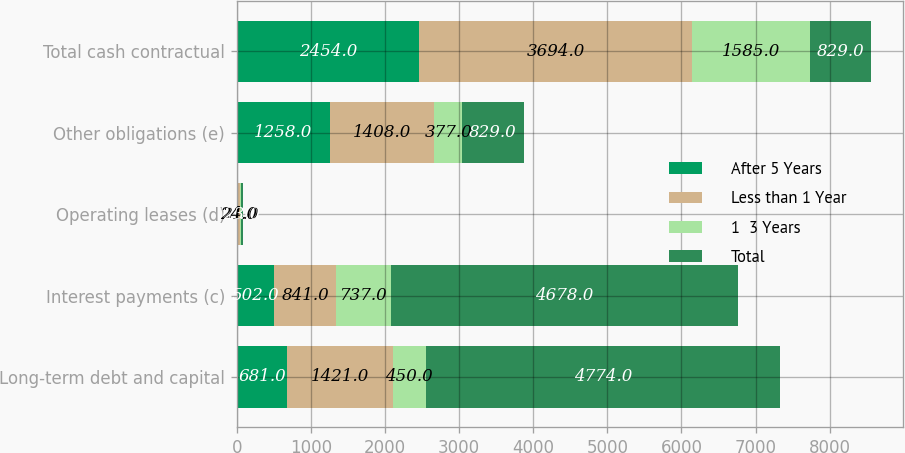Convert chart. <chart><loc_0><loc_0><loc_500><loc_500><stacked_bar_chart><ecel><fcel>Long-term debt and capital<fcel>Interest payments (c)<fcel>Operating leases (d)<fcel>Other obligations (e)<fcel>Total cash contractual<nl><fcel>After 5 Years<fcel>681<fcel>502<fcel>13<fcel>1258<fcel>2454<nl><fcel>Less than 1 Year<fcel>1421<fcel>841<fcel>24<fcel>1408<fcel>3694<nl><fcel>1  3 Years<fcel>450<fcel>737<fcel>21<fcel>377<fcel>1585<nl><fcel>Total<fcel>4774<fcel>4678<fcel>23<fcel>829<fcel>829<nl></chart> 